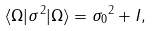<formula> <loc_0><loc_0><loc_500><loc_500>\langle \Omega | \sigma ^ { 2 } | \Omega \rangle = { \sigma _ { 0 } } ^ { 2 } + I ,</formula> 